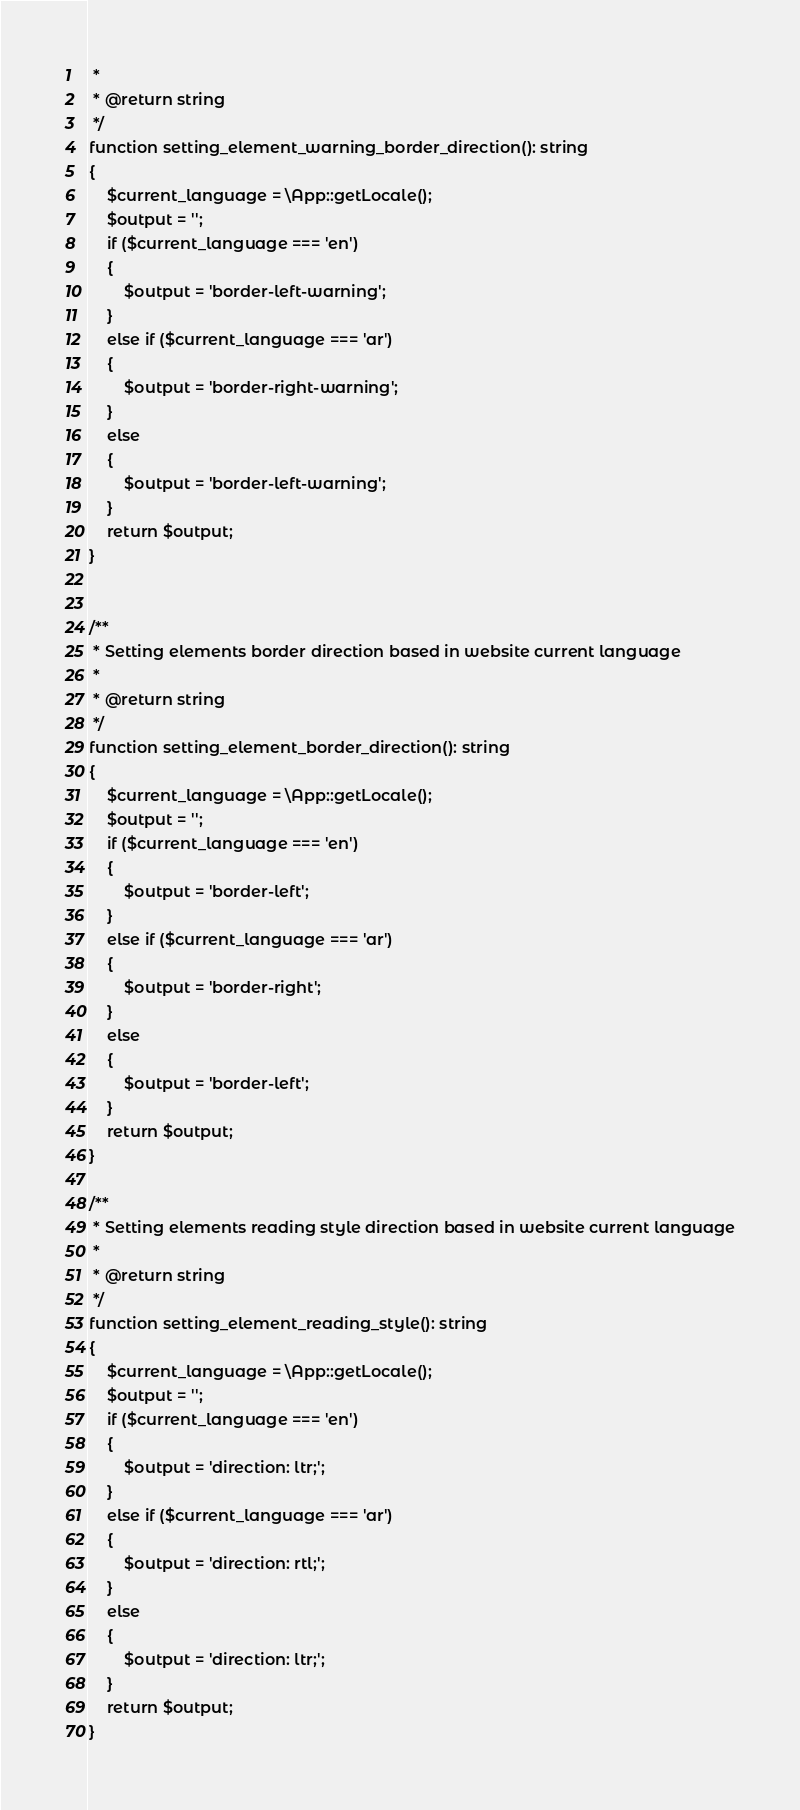Convert code to text. <code><loc_0><loc_0><loc_500><loc_500><_PHP_> *
 * @return string
 */
function setting_element_warning_border_direction(): string
{
    $current_language = \App::getLocale();
    $output = '';
    if ($current_language === 'en')
    {
        $output = 'border-left-warning';
    }
    else if ($current_language === 'ar')
    {
        $output = 'border-right-warning';
    }
    else
    {
        $output = 'border-left-warning';
    }
    return $output;
}


/**
 * Setting elements border direction based in website current language
 *
 * @return string
 */
function setting_element_border_direction(): string
{
    $current_language = \App::getLocale();
    $output = '';
    if ($current_language === 'en')
    {
        $output = 'border-left';
    }
    else if ($current_language === 'ar')
    {
        $output = 'border-right';
    }
    else
    {
        $output = 'border-left';
    }
    return $output;
}

/**
 * Setting elements reading style direction based in website current language
 *
 * @return string
 */
function setting_element_reading_style(): string
{
    $current_language = \App::getLocale();
    $output = '';
    if ($current_language === 'en')
    {
        $output = 'direction: ltr;';
    }
    else if ($current_language === 'ar')
    {
        $output = 'direction: rtl;';
    }
    else
    {
        $output = 'direction: ltr;';
    }
    return $output;
}</code> 